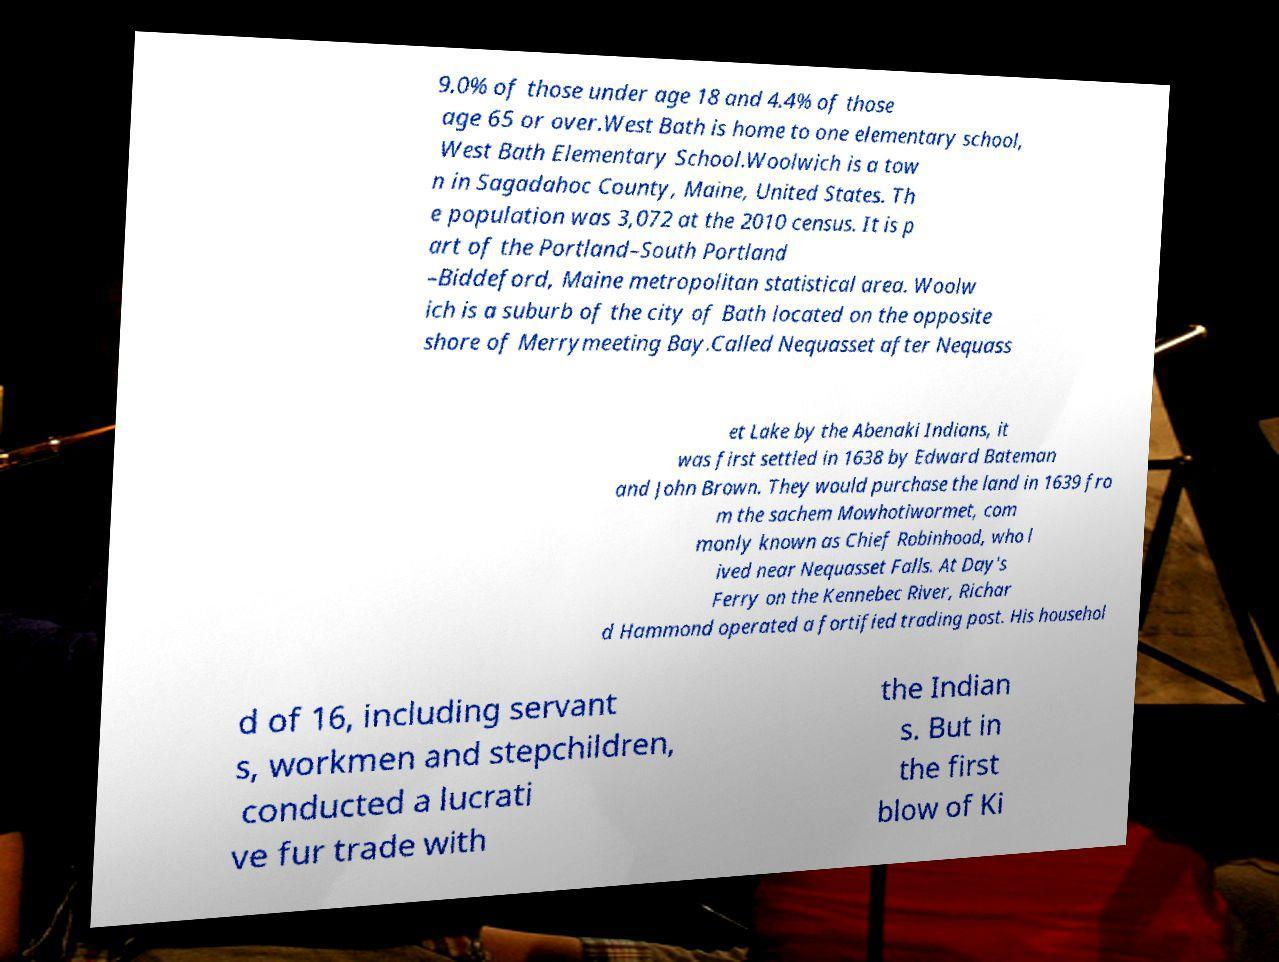For documentation purposes, I need the text within this image transcribed. Could you provide that? 9.0% of those under age 18 and 4.4% of those age 65 or over.West Bath is home to one elementary school, West Bath Elementary School.Woolwich is a tow n in Sagadahoc County, Maine, United States. Th e population was 3,072 at the 2010 census. It is p art of the Portland–South Portland –Biddeford, Maine metropolitan statistical area. Woolw ich is a suburb of the city of Bath located on the opposite shore of Merrymeeting Bay.Called Nequasset after Nequass et Lake by the Abenaki Indians, it was first settled in 1638 by Edward Bateman and John Brown. They would purchase the land in 1639 fro m the sachem Mowhotiwormet, com monly known as Chief Robinhood, who l ived near Nequasset Falls. At Day's Ferry on the Kennebec River, Richar d Hammond operated a fortified trading post. His househol d of 16, including servant s, workmen and stepchildren, conducted a lucrati ve fur trade with the Indian s. But in the first blow of Ki 